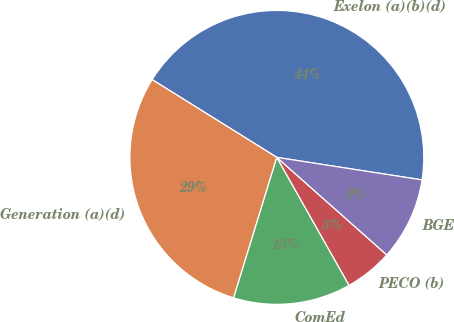Convert chart. <chart><loc_0><loc_0><loc_500><loc_500><pie_chart><fcel>Exelon (a)(b)(d)<fcel>Generation (a)(d)<fcel>ComEd<fcel>PECO (b)<fcel>BGE<nl><fcel>43.57%<fcel>29.13%<fcel>12.93%<fcel>5.27%<fcel>9.1%<nl></chart> 